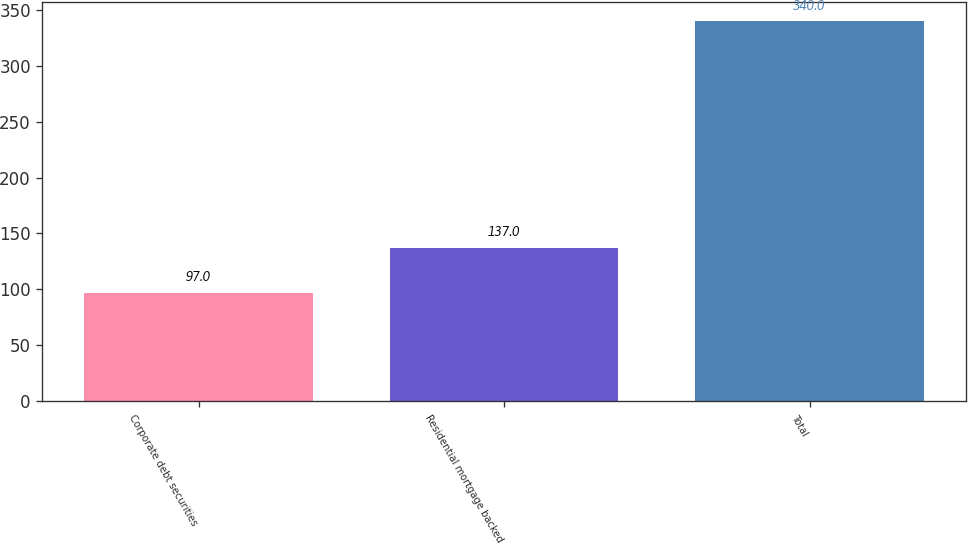<chart> <loc_0><loc_0><loc_500><loc_500><bar_chart><fcel>Corporate debt securities<fcel>Residential mortgage backed<fcel>Total<nl><fcel>97<fcel>137<fcel>340<nl></chart> 